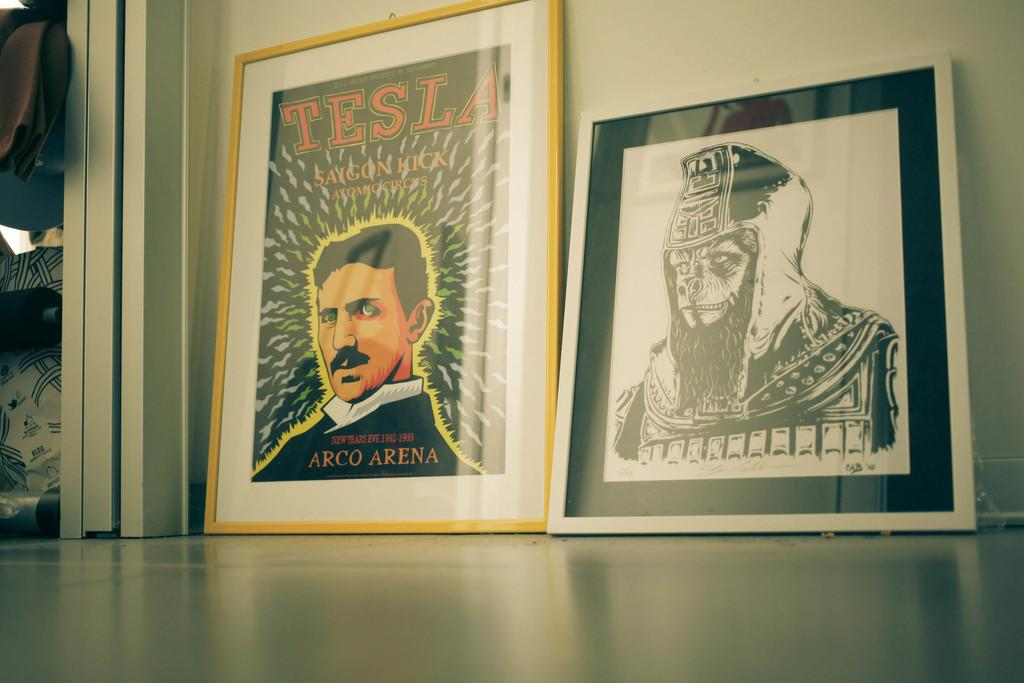<image>
Relay a brief, clear account of the picture shown. An art print of Tesla sits in a yellow frame leaning against the wall. 